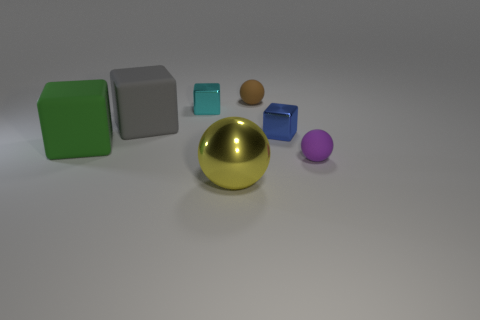How many other objects are there of the same material as the green object?
Offer a terse response. 3. The matte thing that is on the right side of the small cyan metal thing and in front of the blue block is what color?
Provide a short and direct response. Purple. What number of things are either small purple matte balls that are in front of the gray block or large objects?
Your response must be concise. 4. How many other objects are the same color as the metallic sphere?
Your answer should be compact. 0. Is the number of large yellow objects that are behind the metal ball the same as the number of purple shiny objects?
Give a very brief answer. Yes. How many cubes are in front of the small cube that is left of the small metallic object to the right of the yellow metal ball?
Your response must be concise. 3. There is a purple rubber thing; is its size the same as the yellow sphere left of the blue metal cube?
Ensure brevity in your answer.  No. How many gray matte cylinders are there?
Offer a very short reply. 0. There is a yellow sphere in front of the big gray block; is its size the same as the matte cube behind the small blue shiny thing?
Ensure brevity in your answer.  Yes. What is the color of the other shiny object that is the same shape as the small cyan shiny object?
Provide a succinct answer. Blue. 